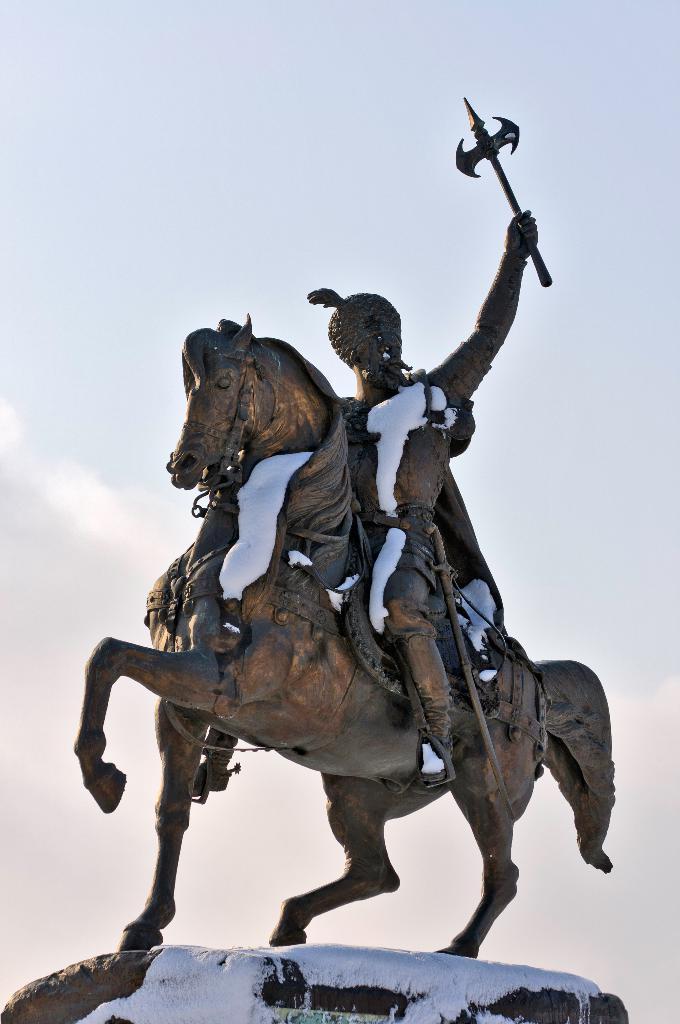How would you summarize this image in a sentence or two? In this image we can see statue of a person on the horse which is on a pedestal. In the background there is sky. 